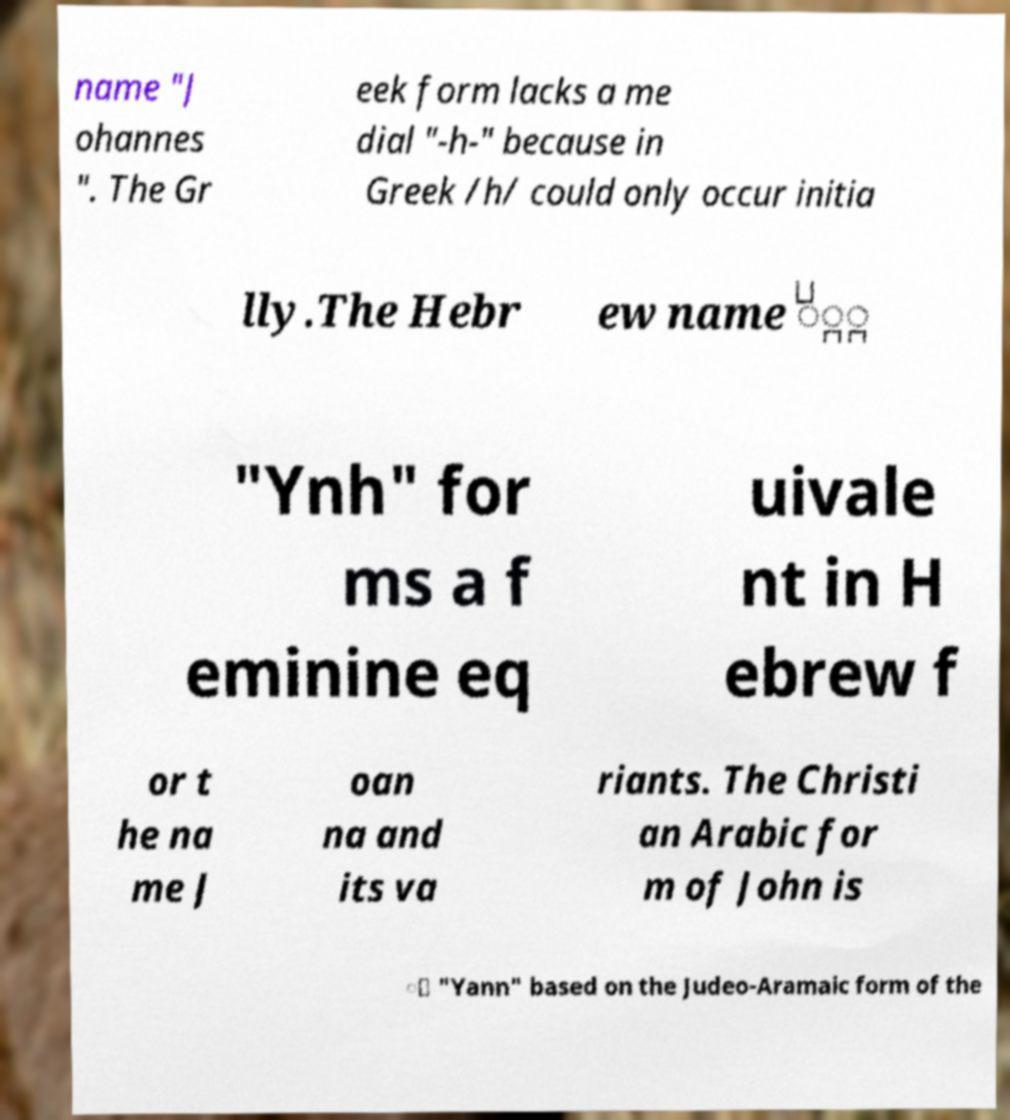Please read and relay the text visible in this image. What does it say? name "J ohannes ". The Gr eek form lacks a me dial "-h-" because in Greek /h/ could only occur initia lly.The Hebr ew name ָָֹ "Ynh" for ms a f eminine eq uivale nt in H ebrew f or t he na me J oan na and its va riants. The Christi an Arabic for m of John is ّ "Yann" based on the Judeo-Aramaic form of the 